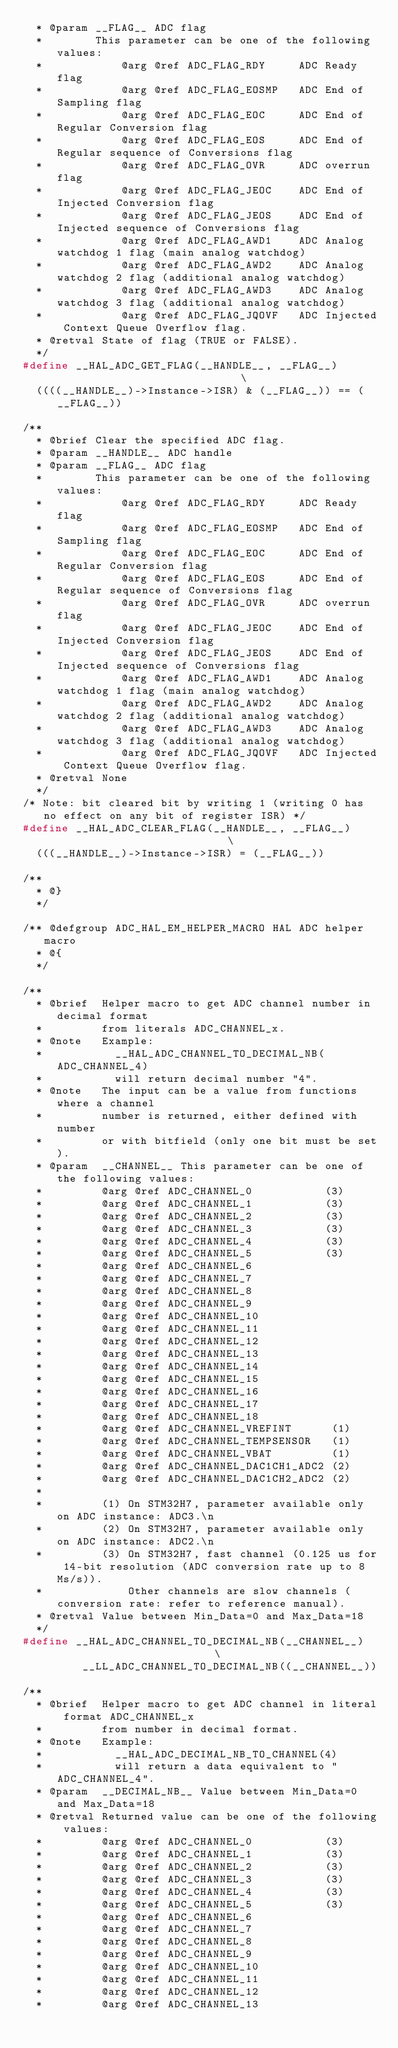Convert code to text. <code><loc_0><loc_0><loc_500><loc_500><_C_>  * @param __FLAG__ ADC flag
  *        This parameter can be one of the following values:
  *            @arg @ref ADC_FLAG_RDY     ADC Ready flag
  *            @arg @ref ADC_FLAG_EOSMP   ADC End of Sampling flag
  *            @arg @ref ADC_FLAG_EOC     ADC End of Regular Conversion flag
  *            @arg @ref ADC_FLAG_EOS     ADC End of Regular sequence of Conversions flag
  *            @arg @ref ADC_FLAG_OVR     ADC overrun flag
  *            @arg @ref ADC_FLAG_JEOC    ADC End of Injected Conversion flag
  *            @arg @ref ADC_FLAG_JEOS    ADC End of Injected sequence of Conversions flag
  *            @arg @ref ADC_FLAG_AWD1    ADC Analog watchdog 1 flag (main analog watchdog)
  *            @arg @ref ADC_FLAG_AWD2    ADC Analog watchdog 2 flag (additional analog watchdog)
  *            @arg @ref ADC_FLAG_AWD3    ADC Analog watchdog 3 flag (additional analog watchdog)
  *            @arg @ref ADC_FLAG_JQOVF   ADC Injected Context Queue Overflow flag.
  * @retval State of flag (TRUE or FALSE).
  */
#define __HAL_ADC_GET_FLAG(__HANDLE__, __FLAG__)                               \
  ((((__HANDLE__)->Instance->ISR) & (__FLAG__)) == (__FLAG__))

/**
  * @brief Clear the specified ADC flag.
  * @param __HANDLE__ ADC handle
  * @param __FLAG__ ADC flag
  *        This parameter can be one of the following values:
  *            @arg @ref ADC_FLAG_RDY     ADC Ready flag
  *            @arg @ref ADC_FLAG_EOSMP   ADC End of Sampling flag
  *            @arg @ref ADC_FLAG_EOC     ADC End of Regular Conversion flag
  *            @arg @ref ADC_FLAG_EOS     ADC End of Regular sequence of Conversions flag
  *            @arg @ref ADC_FLAG_OVR     ADC overrun flag
  *            @arg @ref ADC_FLAG_JEOC    ADC End of Injected Conversion flag
  *            @arg @ref ADC_FLAG_JEOS    ADC End of Injected sequence of Conversions flag
  *            @arg @ref ADC_FLAG_AWD1    ADC Analog watchdog 1 flag (main analog watchdog)
  *            @arg @ref ADC_FLAG_AWD2    ADC Analog watchdog 2 flag (additional analog watchdog)
  *            @arg @ref ADC_FLAG_AWD3    ADC Analog watchdog 3 flag (additional analog watchdog)
  *            @arg @ref ADC_FLAG_JQOVF   ADC Injected Context Queue Overflow flag.
  * @retval None
  */
/* Note: bit cleared bit by writing 1 (writing 0 has no effect on any bit of register ISR) */
#define __HAL_ADC_CLEAR_FLAG(__HANDLE__, __FLAG__)                             \
  (((__HANDLE__)->Instance->ISR) = (__FLAG__))

/**
  * @}
  */

/** @defgroup ADC_HAL_EM_HELPER_MACRO HAL ADC helper macro
  * @{
  */

/**
  * @brief  Helper macro to get ADC channel number in decimal format
  *         from literals ADC_CHANNEL_x.
  * @note   Example:
  *           __HAL_ADC_CHANNEL_TO_DECIMAL_NB(ADC_CHANNEL_4)
  *           will return decimal number "4".
  * @note   The input can be a value from functions where a channel
  *         number is returned, either defined with number
  *         or with bitfield (only one bit must be set).
  * @param  __CHANNEL__ This parameter can be one of the following values:
  *         @arg @ref ADC_CHANNEL_0           (3)
  *         @arg @ref ADC_CHANNEL_1           (3)
  *         @arg @ref ADC_CHANNEL_2           (3)
  *         @arg @ref ADC_CHANNEL_3           (3)
  *         @arg @ref ADC_CHANNEL_4           (3)
  *         @arg @ref ADC_CHANNEL_5           (3)
  *         @arg @ref ADC_CHANNEL_6
  *         @arg @ref ADC_CHANNEL_7
  *         @arg @ref ADC_CHANNEL_8
  *         @arg @ref ADC_CHANNEL_9
  *         @arg @ref ADC_CHANNEL_10
  *         @arg @ref ADC_CHANNEL_11
  *         @arg @ref ADC_CHANNEL_12
  *         @arg @ref ADC_CHANNEL_13
  *         @arg @ref ADC_CHANNEL_14
  *         @arg @ref ADC_CHANNEL_15
  *         @arg @ref ADC_CHANNEL_16
  *         @arg @ref ADC_CHANNEL_17
  *         @arg @ref ADC_CHANNEL_18
  *         @arg @ref ADC_CHANNEL_VREFINT      (1)
  *         @arg @ref ADC_CHANNEL_TEMPSENSOR   (1)
  *         @arg @ref ADC_CHANNEL_VBAT         (1)
  *         @arg @ref ADC_CHANNEL_DAC1CH1_ADC2 (2)
  *         @arg @ref ADC_CHANNEL_DAC1CH2_ADC2 (2)
  *
  *         (1) On STM32H7, parameter available only on ADC instance: ADC3.\n
  *         (2) On STM32H7, parameter available only on ADC instance: ADC2.\n
  *         (3) On STM32H7, fast channel (0.125 us for 14-bit resolution (ADC conversion rate up to 8 Ms/s)).
  *             Other channels are slow channels (conversion rate: refer to reference manual).
  * @retval Value between Min_Data=0 and Max_Data=18
  */
#define __HAL_ADC_CHANNEL_TO_DECIMAL_NB(__CHANNEL__)                           \
         __LL_ADC_CHANNEL_TO_DECIMAL_NB((__CHANNEL__))

/**
  * @brief  Helper macro to get ADC channel in literal format ADC_CHANNEL_x
  *         from number in decimal format.
  * @note   Example:
  *           __HAL_ADC_DECIMAL_NB_TO_CHANNEL(4)
  *           will return a data equivalent to "ADC_CHANNEL_4".
  * @param  __DECIMAL_NB__ Value between Min_Data=0 and Max_Data=18
  * @retval Returned value can be one of the following values:
  *         @arg @ref ADC_CHANNEL_0           (3)
  *         @arg @ref ADC_CHANNEL_1           (3)
  *         @arg @ref ADC_CHANNEL_2           (3)
  *         @arg @ref ADC_CHANNEL_3           (3)
  *         @arg @ref ADC_CHANNEL_4           (3)
  *         @arg @ref ADC_CHANNEL_5           (3)
  *         @arg @ref ADC_CHANNEL_6
  *         @arg @ref ADC_CHANNEL_7
  *         @arg @ref ADC_CHANNEL_8
  *         @arg @ref ADC_CHANNEL_9
  *         @arg @ref ADC_CHANNEL_10
  *         @arg @ref ADC_CHANNEL_11
  *         @arg @ref ADC_CHANNEL_12
  *         @arg @ref ADC_CHANNEL_13</code> 